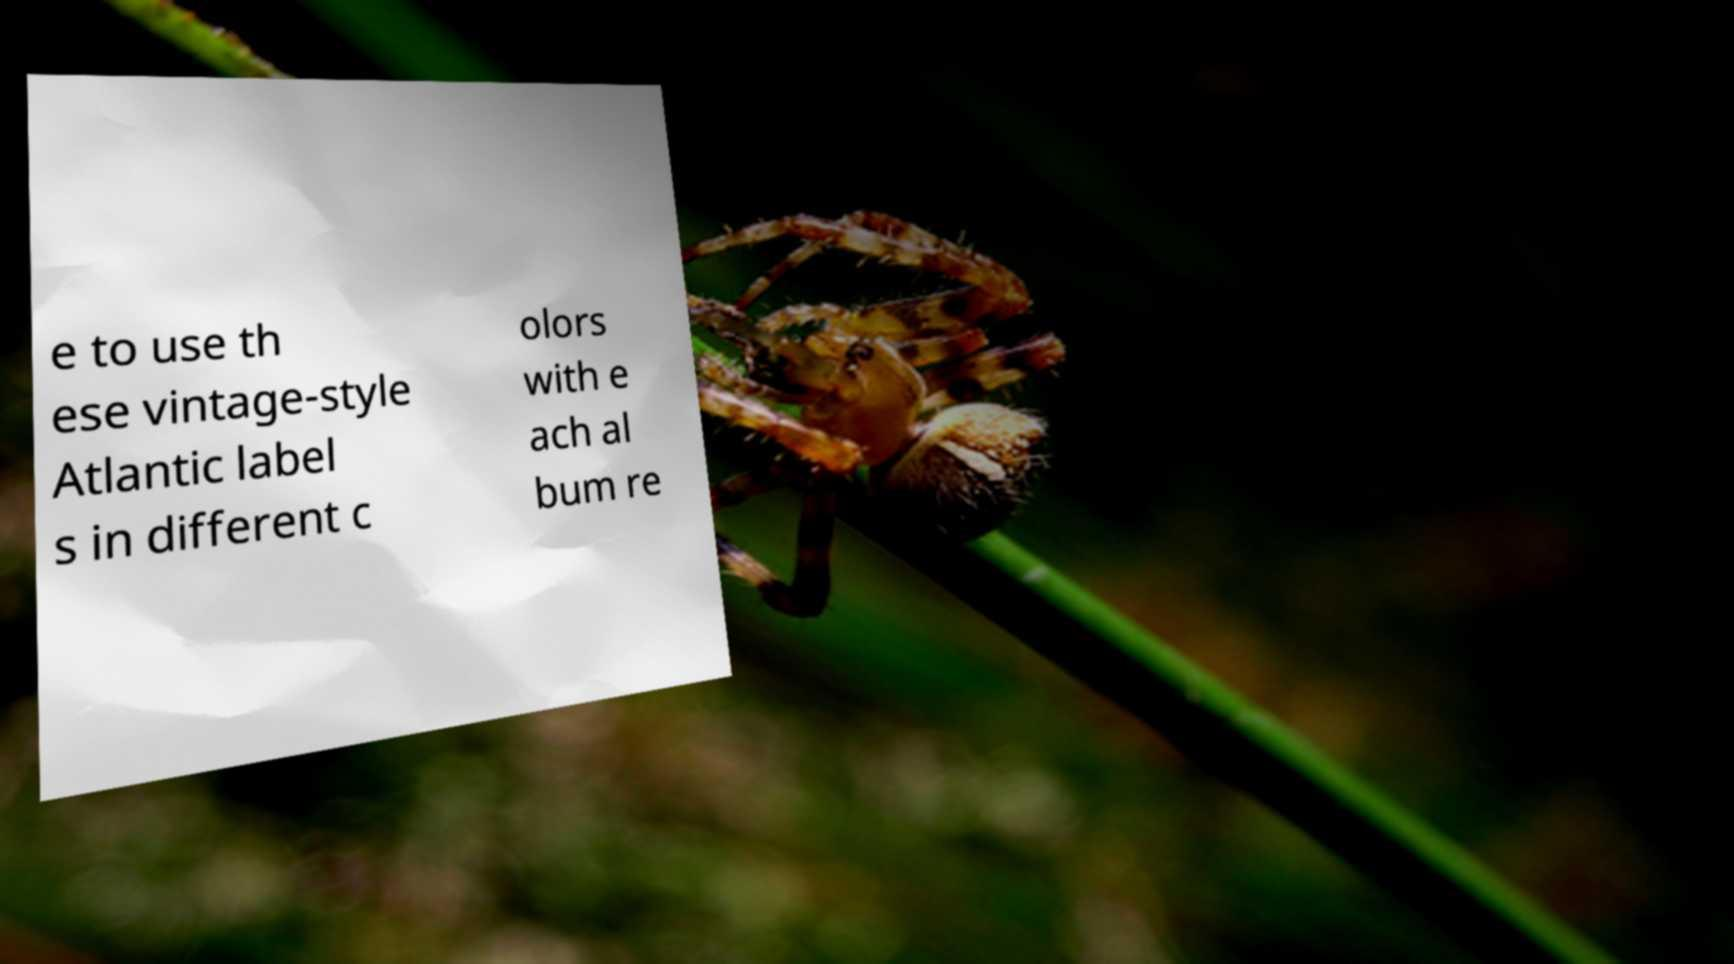Can you accurately transcribe the text from the provided image for me? e to use th ese vintage-style Atlantic label s in different c olors with e ach al bum re 